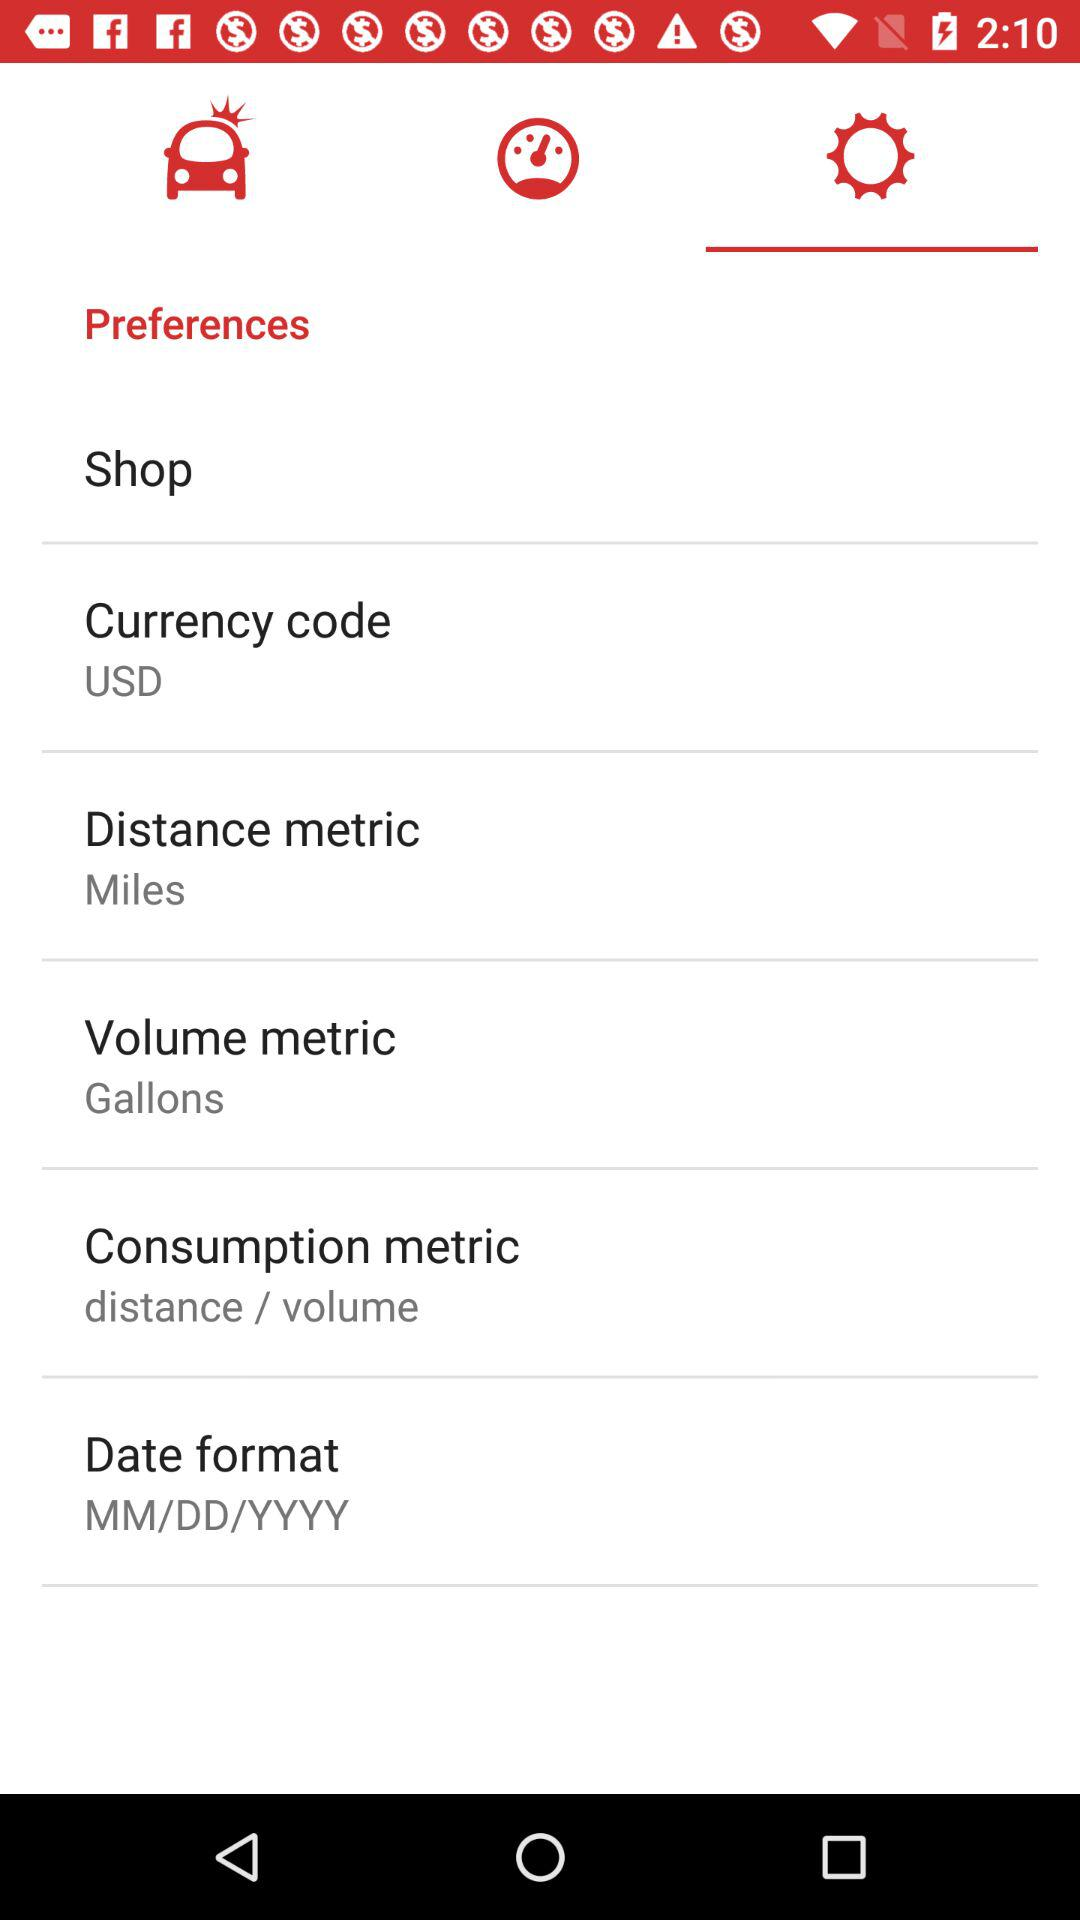What is the format for dates? The format for dates is MM/DD/YYYY. 